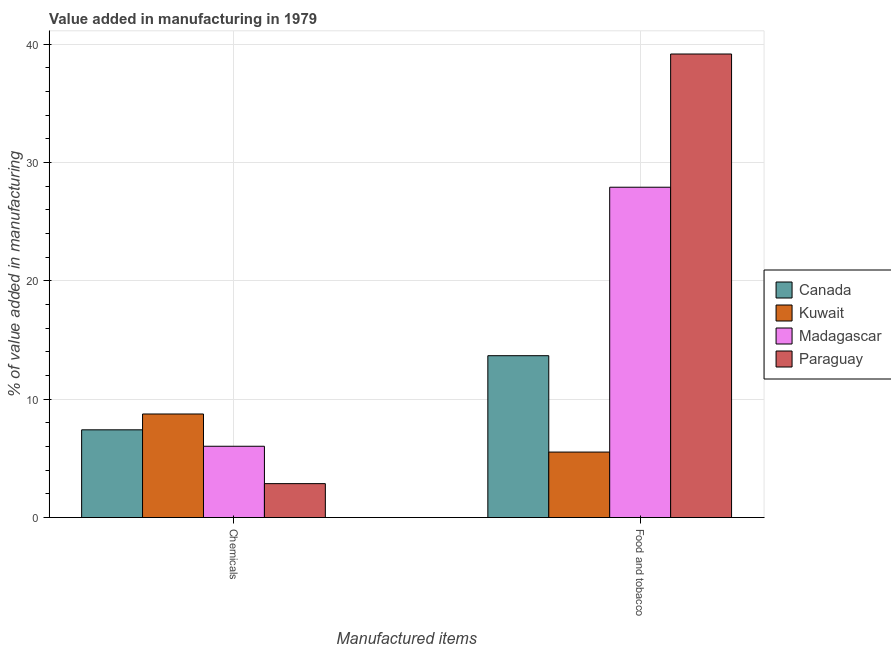How many groups of bars are there?
Provide a short and direct response. 2. Are the number of bars per tick equal to the number of legend labels?
Make the answer very short. Yes. What is the label of the 2nd group of bars from the left?
Make the answer very short. Food and tobacco. What is the value added by manufacturing food and tobacco in Madagascar?
Make the answer very short. 27.92. Across all countries, what is the maximum value added by manufacturing food and tobacco?
Ensure brevity in your answer.  39.18. Across all countries, what is the minimum value added by  manufacturing chemicals?
Provide a short and direct response. 2.87. In which country was the value added by manufacturing food and tobacco maximum?
Ensure brevity in your answer.  Paraguay. In which country was the value added by manufacturing food and tobacco minimum?
Keep it short and to the point. Kuwait. What is the total value added by manufacturing food and tobacco in the graph?
Give a very brief answer. 86.32. What is the difference between the value added by  manufacturing chemicals in Canada and that in Madagascar?
Your answer should be compact. 1.39. What is the difference between the value added by manufacturing food and tobacco in Canada and the value added by  manufacturing chemicals in Paraguay?
Provide a succinct answer. 10.81. What is the average value added by  manufacturing chemicals per country?
Your response must be concise. 6.27. What is the difference between the value added by  manufacturing chemicals and value added by manufacturing food and tobacco in Canada?
Your answer should be compact. -6.27. What is the ratio of the value added by  manufacturing chemicals in Canada to that in Paraguay?
Your answer should be compact. 2.59. What does the 3rd bar from the left in Chemicals represents?
Provide a short and direct response. Madagascar. What does the 2nd bar from the right in Chemicals represents?
Ensure brevity in your answer.  Madagascar. How many bars are there?
Keep it short and to the point. 8. Are all the bars in the graph horizontal?
Your answer should be very brief. No. How many countries are there in the graph?
Give a very brief answer. 4. Are the values on the major ticks of Y-axis written in scientific E-notation?
Your answer should be compact. No. Does the graph contain any zero values?
Your response must be concise. No. Does the graph contain grids?
Make the answer very short. Yes. Where does the legend appear in the graph?
Ensure brevity in your answer.  Center right. How many legend labels are there?
Provide a short and direct response. 4. How are the legend labels stacked?
Keep it short and to the point. Vertical. What is the title of the graph?
Offer a terse response. Value added in manufacturing in 1979. What is the label or title of the X-axis?
Your response must be concise. Manufactured items. What is the label or title of the Y-axis?
Give a very brief answer. % of value added in manufacturing. What is the % of value added in manufacturing in Canada in Chemicals?
Give a very brief answer. 7.42. What is the % of value added in manufacturing of Kuwait in Chemicals?
Provide a short and direct response. 8.75. What is the % of value added in manufacturing of Madagascar in Chemicals?
Provide a short and direct response. 6.03. What is the % of value added in manufacturing of Paraguay in Chemicals?
Your answer should be very brief. 2.87. What is the % of value added in manufacturing in Canada in Food and tobacco?
Offer a very short reply. 13.68. What is the % of value added in manufacturing in Kuwait in Food and tobacco?
Your answer should be compact. 5.54. What is the % of value added in manufacturing of Madagascar in Food and tobacco?
Provide a succinct answer. 27.92. What is the % of value added in manufacturing of Paraguay in Food and tobacco?
Offer a very short reply. 39.18. Across all Manufactured items, what is the maximum % of value added in manufacturing in Canada?
Ensure brevity in your answer.  13.68. Across all Manufactured items, what is the maximum % of value added in manufacturing in Kuwait?
Your answer should be compact. 8.75. Across all Manufactured items, what is the maximum % of value added in manufacturing of Madagascar?
Offer a very short reply. 27.92. Across all Manufactured items, what is the maximum % of value added in manufacturing of Paraguay?
Offer a terse response. 39.18. Across all Manufactured items, what is the minimum % of value added in manufacturing in Canada?
Provide a succinct answer. 7.42. Across all Manufactured items, what is the minimum % of value added in manufacturing in Kuwait?
Keep it short and to the point. 5.54. Across all Manufactured items, what is the minimum % of value added in manufacturing of Madagascar?
Offer a very short reply. 6.03. Across all Manufactured items, what is the minimum % of value added in manufacturing in Paraguay?
Offer a very short reply. 2.87. What is the total % of value added in manufacturing in Canada in the graph?
Your answer should be compact. 21.1. What is the total % of value added in manufacturing in Kuwait in the graph?
Offer a terse response. 14.29. What is the total % of value added in manufacturing of Madagascar in the graph?
Provide a short and direct response. 33.95. What is the total % of value added in manufacturing in Paraguay in the graph?
Keep it short and to the point. 42.05. What is the difference between the % of value added in manufacturing of Canada in Chemicals and that in Food and tobacco?
Your answer should be very brief. -6.27. What is the difference between the % of value added in manufacturing in Kuwait in Chemicals and that in Food and tobacco?
Make the answer very short. 3.22. What is the difference between the % of value added in manufacturing in Madagascar in Chemicals and that in Food and tobacco?
Your response must be concise. -21.89. What is the difference between the % of value added in manufacturing of Paraguay in Chemicals and that in Food and tobacco?
Make the answer very short. -36.32. What is the difference between the % of value added in manufacturing in Canada in Chemicals and the % of value added in manufacturing in Kuwait in Food and tobacco?
Provide a succinct answer. 1.88. What is the difference between the % of value added in manufacturing of Canada in Chemicals and the % of value added in manufacturing of Madagascar in Food and tobacco?
Your answer should be very brief. -20.51. What is the difference between the % of value added in manufacturing in Canada in Chemicals and the % of value added in manufacturing in Paraguay in Food and tobacco?
Keep it short and to the point. -31.77. What is the difference between the % of value added in manufacturing of Kuwait in Chemicals and the % of value added in manufacturing of Madagascar in Food and tobacco?
Provide a succinct answer. -19.17. What is the difference between the % of value added in manufacturing of Kuwait in Chemicals and the % of value added in manufacturing of Paraguay in Food and tobacco?
Make the answer very short. -30.43. What is the difference between the % of value added in manufacturing of Madagascar in Chemicals and the % of value added in manufacturing of Paraguay in Food and tobacco?
Keep it short and to the point. -33.16. What is the average % of value added in manufacturing of Canada per Manufactured items?
Provide a succinct answer. 10.55. What is the average % of value added in manufacturing of Kuwait per Manufactured items?
Keep it short and to the point. 7.14. What is the average % of value added in manufacturing of Madagascar per Manufactured items?
Make the answer very short. 16.97. What is the average % of value added in manufacturing in Paraguay per Manufactured items?
Offer a very short reply. 21.02. What is the difference between the % of value added in manufacturing in Canada and % of value added in manufacturing in Kuwait in Chemicals?
Your answer should be compact. -1.34. What is the difference between the % of value added in manufacturing of Canada and % of value added in manufacturing of Madagascar in Chemicals?
Provide a succinct answer. 1.39. What is the difference between the % of value added in manufacturing of Canada and % of value added in manufacturing of Paraguay in Chemicals?
Offer a very short reply. 4.55. What is the difference between the % of value added in manufacturing of Kuwait and % of value added in manufacturing of Madagascar in Chemicals?
Provide a short and direct response. 2.73. What is the difference between the % of value added in manufacturing in Kuwait and % of value added in manufacturing in Paraguay in Chemicals?
Your answer should be very brief. 5.89. What is the difference between the % of value added in manufacturing in Madagascar and % of value added in manufacturing in Paraguay in Chemicals?
Your response must be concise. 3.16. What is the difference between the % of value added in manufacturing in Canada and % of value added in manufacturing in Kuwait in Food and tobacco?
Offer a very short reply. 8.15. What is the difference between the % of value added in manufacturing in Canada and % of value added in manufacturing in Madagascar in Food and tobacco?
Provide a succinct answer. -14.24. What is the difference between the % of value added in manufacturing in Canada and % of value added in manufacturing in Paraguay in Food and tobacco?
Keep it short and to the point. -25.5. What is the difference between the % of value added in manufacturing in Kuwait and % of value added in manufacturing in Madagascar in Food and tobacco?
Offer a very short reply. -22.39. What is the difference between the % of value added in manufacturing of Kuwait and % of value added in manufacturing of Paraguay in Food and tobacco?
Give a very brief answer. -33.65. What is the difference between the % of value added in manufacturing of Madagascar and % of value added in manufacturing of Paraguay in Food and tobacco?
Make the answer very short. -11.26. What is the ratio of the % of value added in manufacturing of Canada in Chemicals to that in Food and tobacco?
Offer a very short reply. 0.54. What is the ratio of the % of value added in manufacturing in Kuwait in Chemicals to that in Food and tobacco?
Offer a terse response. 1.58. What is the ratio of the % of value added in manufacturing of Madagascar in Chemicals to that in Food and tobacco?
Offer a terse response. 0.22. What is the ratio of the % of value added in manufacturing of Paraguay in Chemicals to that in Food and tobacco?
Provide a succinct answer. 0.07. What is the difference between the highest and the second highest % of value added in manufacturing in Canada?
Ensure brevity in your answer.  6.27. What is the difference between the highest and the second highest % of value added in manufacturing in Kuwait?
Ensure brevity in your answer.  3.22. What is the difference between the highest and the second highest % of value added in manufacturing in Madagascar?
Offer a very short reply. 21.89. What is the difference between the highest and the second highest % of value added in manufacturing of Paraguay?
Ensure brevity in your answer.  36.32. What is the difference between the highest and the lowest % of value added in manufacturing of Canada?
Ensure brevity in your answer.  6.27. What is the difference between the highest and the lowest % of value added in manufacturing in Kuwait?
Offer a terse response. 3.22. What is the difference between the highest and the lowest % of value added in manufacturing of Madagascar?
Provide a succinct answer. 21.89. What is the difference between the highest and the lowest % of value added in manufacturing in Paraguay?
Your answer should be compact. 36.32. 